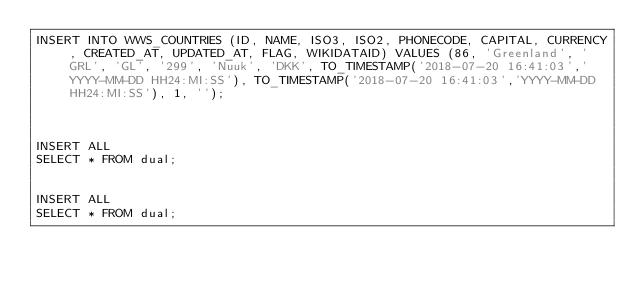<code> <loc_0><loc_0><loc_500><loc_500><_SQL_>INSERT INTO WWS_COUNTRIES (ID, NAME, ISO3, ISO2, PHONECODE, CAPITAL, CURRENCY, CREATED_AT, UPDATED_AT, FLAG, WIKIDATAID) VALUES (86, 'Greenland', 'GRL', 'GL', '299', 'Nuuk', 'DKK', TO_TIMESTAMP('2018-07-20 16:41:03','YYYY-MM-DD HH24:MI:SS'), TO_TIMESTAMP('2018-07-20 16:41:03','YYYY-MM-DD HH24:MI:SS'), 1, '');



INSERT ALL
SELECT * FROM dual;


INSERT ALL
SELECT * FROM dual;</code> 